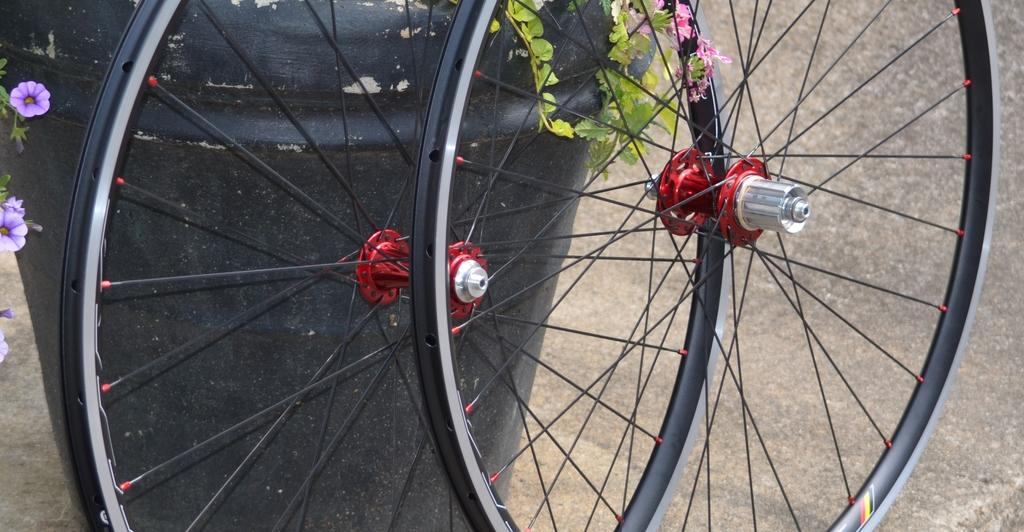What objects are on the ground in the image? There are wheels on the ground in the image. What is located behind the wheels? There is a black color drum behind the wheels. What type of vegetation is present in the image? There are flowers on a plant in the image. What type of boot can be seen on the person in the image? There is no person present in the image, so it is not possible to determine if there is a boot or any other clothing item. 